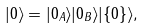<formula> <loc_0><loc_0><loc_500><loc_500>| 0 \rangle = | 0 _ { A } \rangle | 0 _ { B } \rangle | \{ 0 \} \rangle ,</formula> 